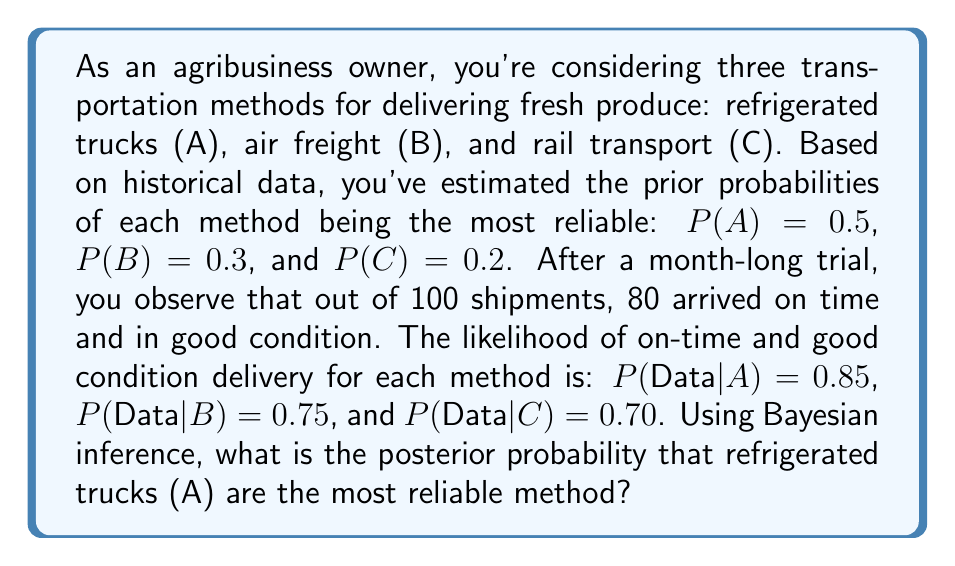Show me your answer to this math problem. To solve this problem, we'll use Bayes' theorem:

$$P(A|Data) = \frac{P(Data|A) \cdot P(A)}{P(Data)}$$

Where:
- $P(A|Data)$ is the posterior probability of A being the most reliable given the observed data
- $P(Data|A)$ is the likelihood of the observed data given A is the most reliable
- $P(A)$ is the prior probability of A being the most reliable
- $P(Data)$ is the total probability of observing the data

We're given:
- $P(A) = 0.5$
- $P(B) = 0.3$
- $P(C) = 0.2$
- $P(Data|A) = 0.85$
- $P(Data|B) = 0.75$
- $P(Data|C) = 0.70$

Step 1: Calculate $P(Data)$ using the law of total probability:

$$P(Data) = P(Data|A) \cdot P(A) + P(Data|B) \cdot P(B) + P(Data|C) \cdot P(C)$$
$$P(Data) = 0.85 \cdot 0.5 + 0.75 \cdot 0.3 + 0.70 \cdot 0.2$$
$$P(Data) = 0.425 + 0.225 + 0.140 = 0.790$$

Step 2: Apply Bayes' theorem to calculate the posterior probability:

$$P(A|Data) = \frac{P(Data|A) \cdot P(A)}{P(Data)}$$
$$P(A|Data) = \frac{0.85 \cdot 0.5}{0.790}$$
$$P(A|Data) = \frac{0.425}{0.790} \approx 0.5380$$

Therefore, the posterior probability that refrigerated trucks (A) are the most reliable method is approximately 0.5380 or 53.80%.
Answer: The posterior probability that refrigerated trucks (A) are the most reliable method is approximately 0.5380 or 53.80%. 